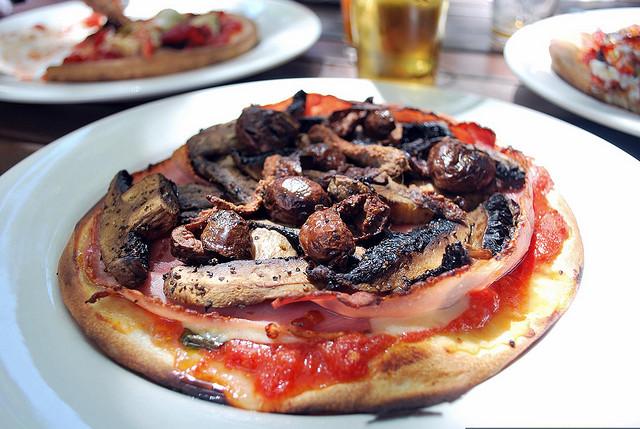Has the pizza finished cooking?
Keep it brief. Yes. Are there mushrooms on the pizza?
Answer briefly. Yes. What shape is the pizza?
Short answer required. Round. 